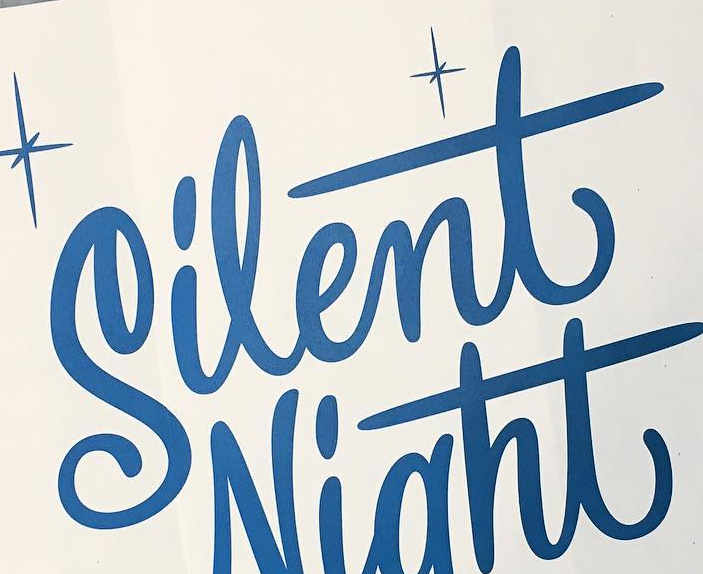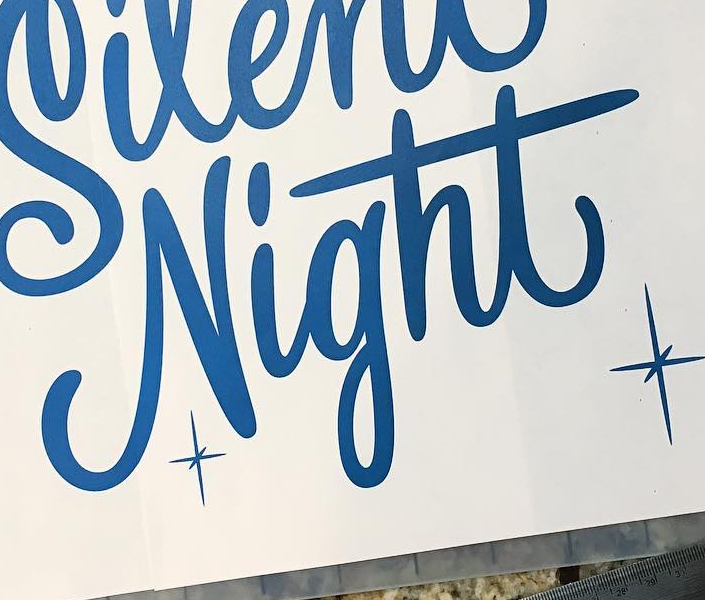Transcribe the words shown in these images in order, separated by a semicolon. Silent; Night 